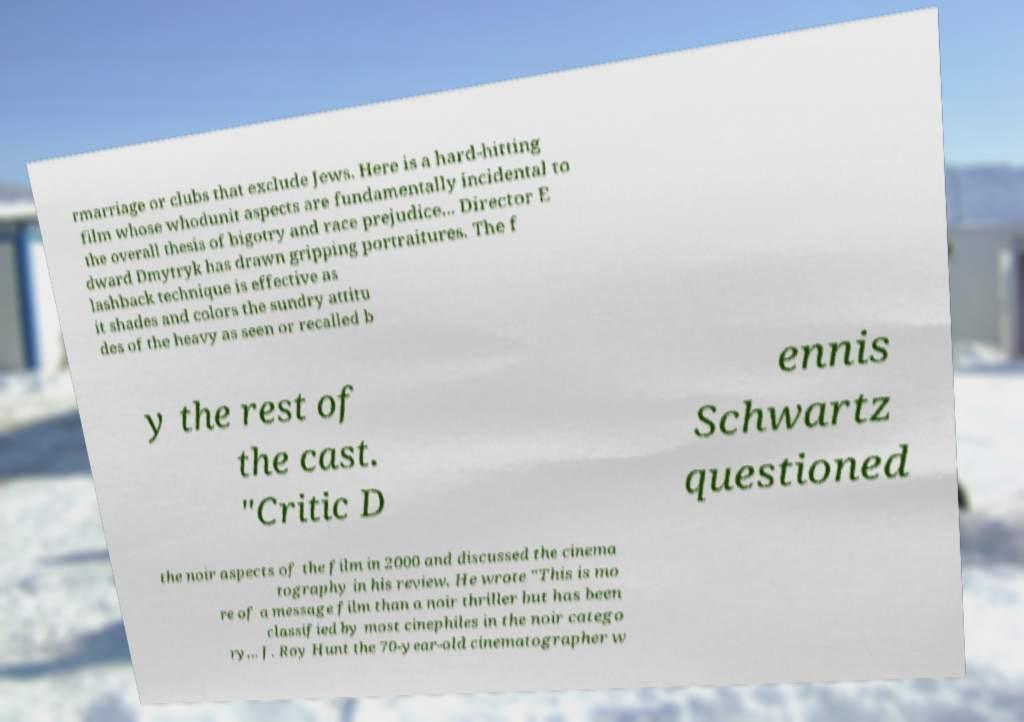For documentation purposes, I need the text within this image transcribed. Could you provide that? rmarriage or clubs that exclude Jews. Here is a hard-hitting film whose whodunit aspects are fundamentally incidental to the overall thesis of bigotry and race prejudice... Director E dward Dmytryk has drawn gripping portraitures. The f lashback technique is effective as it shades and colors the sundry attitu des of the heavy as seen or recalled b y the rest of the cast. "Critic D ennis Schwartz questioned the noir aspects of the film in 2000 and discussed the cinema tography in his review. He wrote "This is mo re of a message film than a noir thriller but has been classified by most cinephiles in the noir catego ry... J. Roy Hunt the 70-year-old cinematographer w 